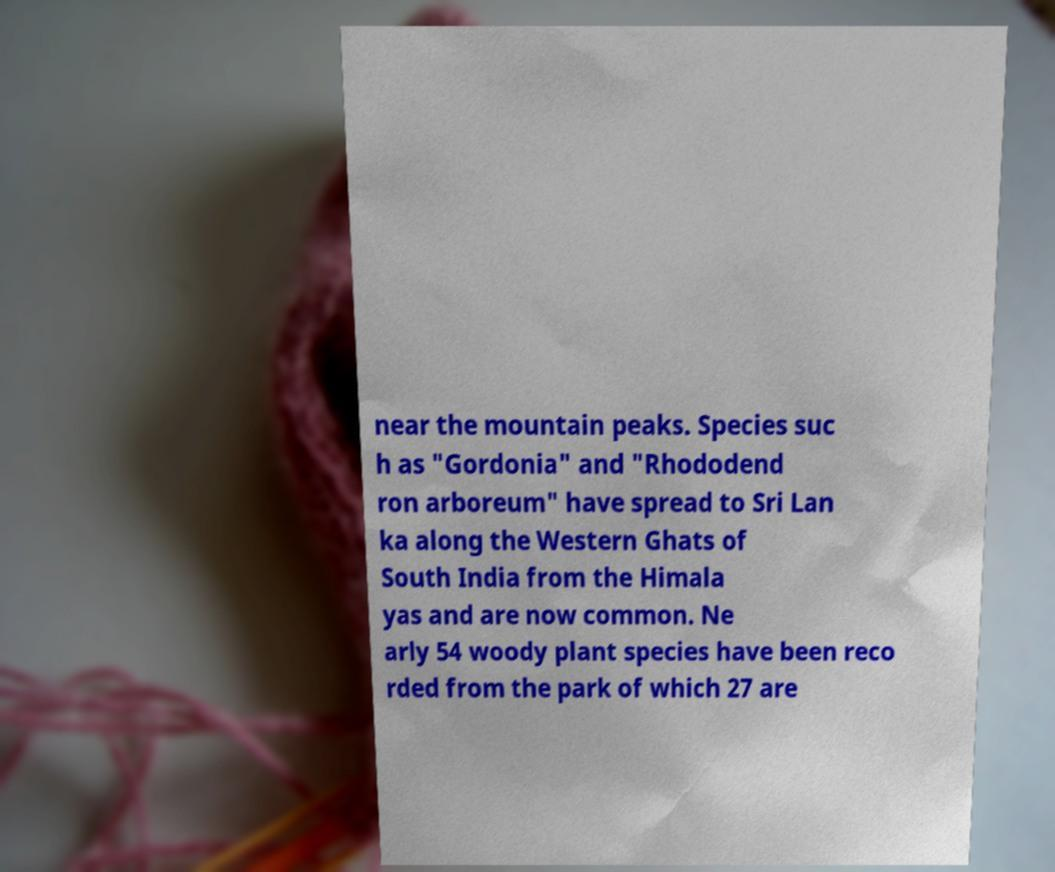What messages or text are displayed in this image? I need them in a readable, typed format. near the mountain peaks. Species suc h as "Gordonia" and "Rhododend ron arboreum" have spread to Sri Lan ka along the Western Ghats of South India from the Himala yas and are now common. Ne arly 54 woody plant species have been reco rded from the park of which 27 are 